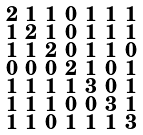<formula> <loc_0><loc_0><loc_500><loc_500>\begin{smallmatrix} 2 & 1 & 1 & 0 & 1 & 1 & 1 \\ 1 & 2 & 1 & 0 & 1 & 1 & 1 \\ 1 & 1 & 2 & 0 & 1 & 1 & 0 \\ 0 & 0 & 0 & 2 & 1 & 0 & 1 \\ 1 & 1 & 1 & 1 & 3 & 0 & 1 \\ 1 & 1 & 1 & 0 & 0 & 3 & 1 \\ 1 & 1 & 0 & 1 & 1 & 1 & 3 \end{smallmatrix}</formula> 